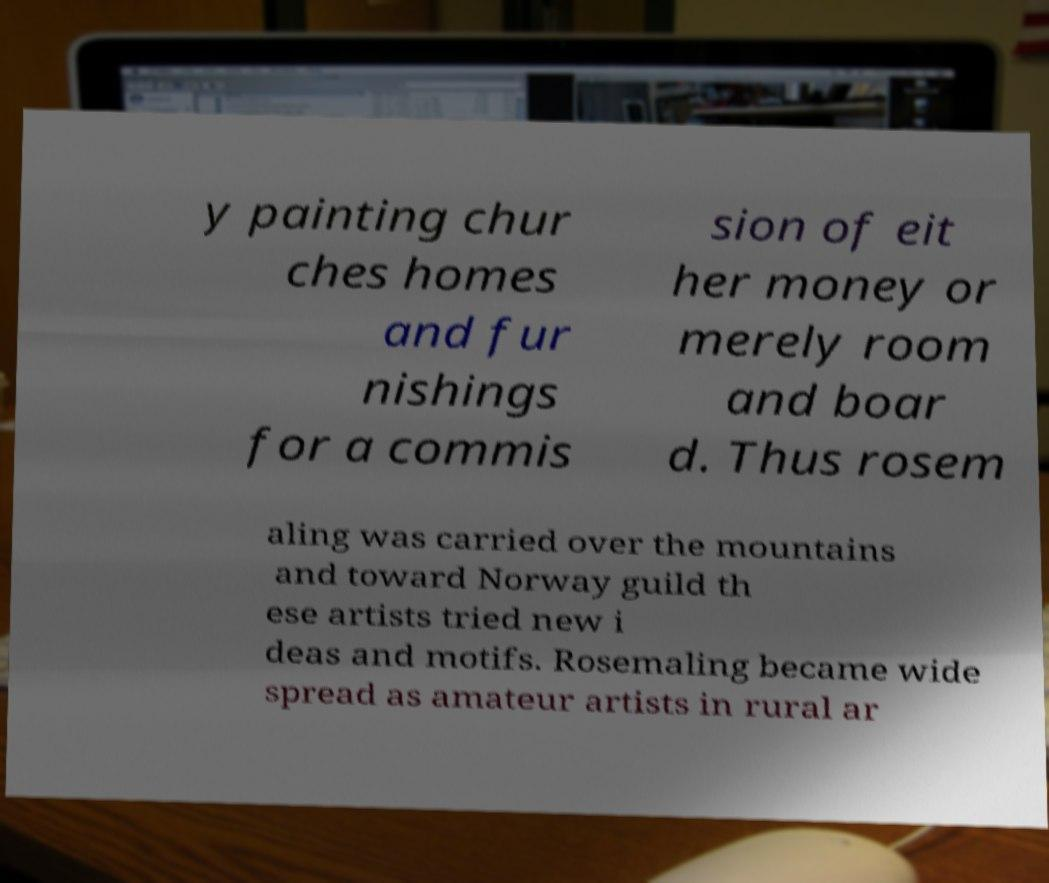Could you assist in decoding the text presented in this image and type it out clearly? y painting chur ches homes and fur nishings for a commis sion of eit her money or merely room and boar d. Thus rosem aling was carried over the mountains and toward Norway guild th ese artists tried new i deas and motifs. Rosemaling became wide spread as amateur artists in rural ar 